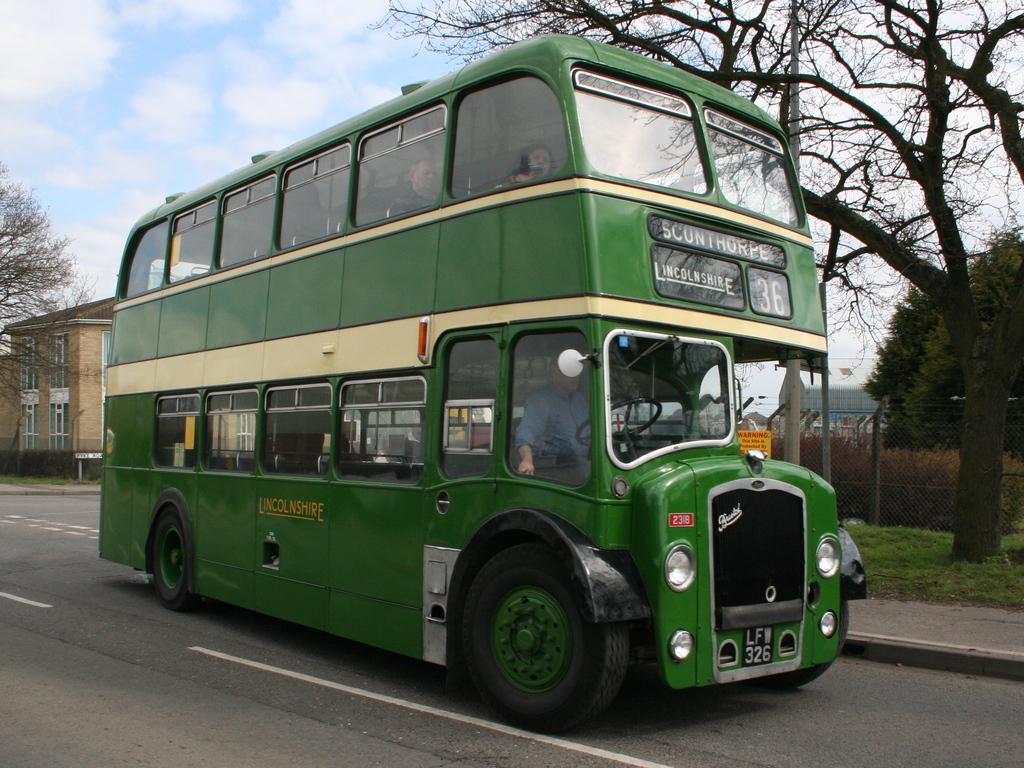Where is the bus going to?
Provide a succinct answer. Sconthorpe. What is the bus number?
Ensure brevity in your answer.  36. 